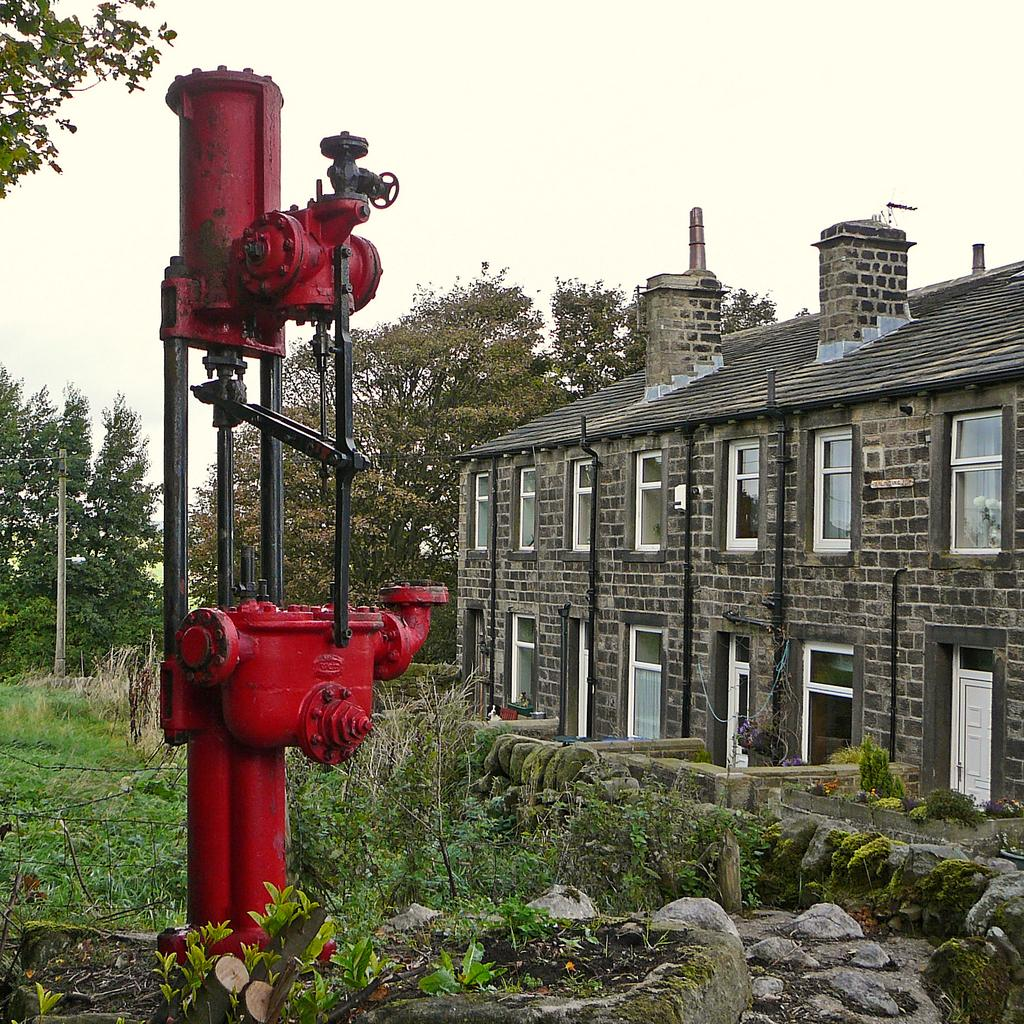What can be seen in the foreground of the image? In the foreground of the image, there are stones, a fence, grass, and buildings. Can you describe the objects in the foreground? The objects in the foreground include stones, a fence, and buildings. What is the texture of the ground in the foreground? The ground in the foreground is covered with grass. What is visible in the background of the image? In the background of the image, there are trees, a pole, and the sky. Can you tell if the image was taken during the day or night? The image was likely taken during the day, as the sky is visible. How many watches are visible on the trees in the background? There are no watches visible on the trees in the background; only trees, a pole, and the sky are present. What is the size of the dolls in the foreground? There are no dolls present in the image. 